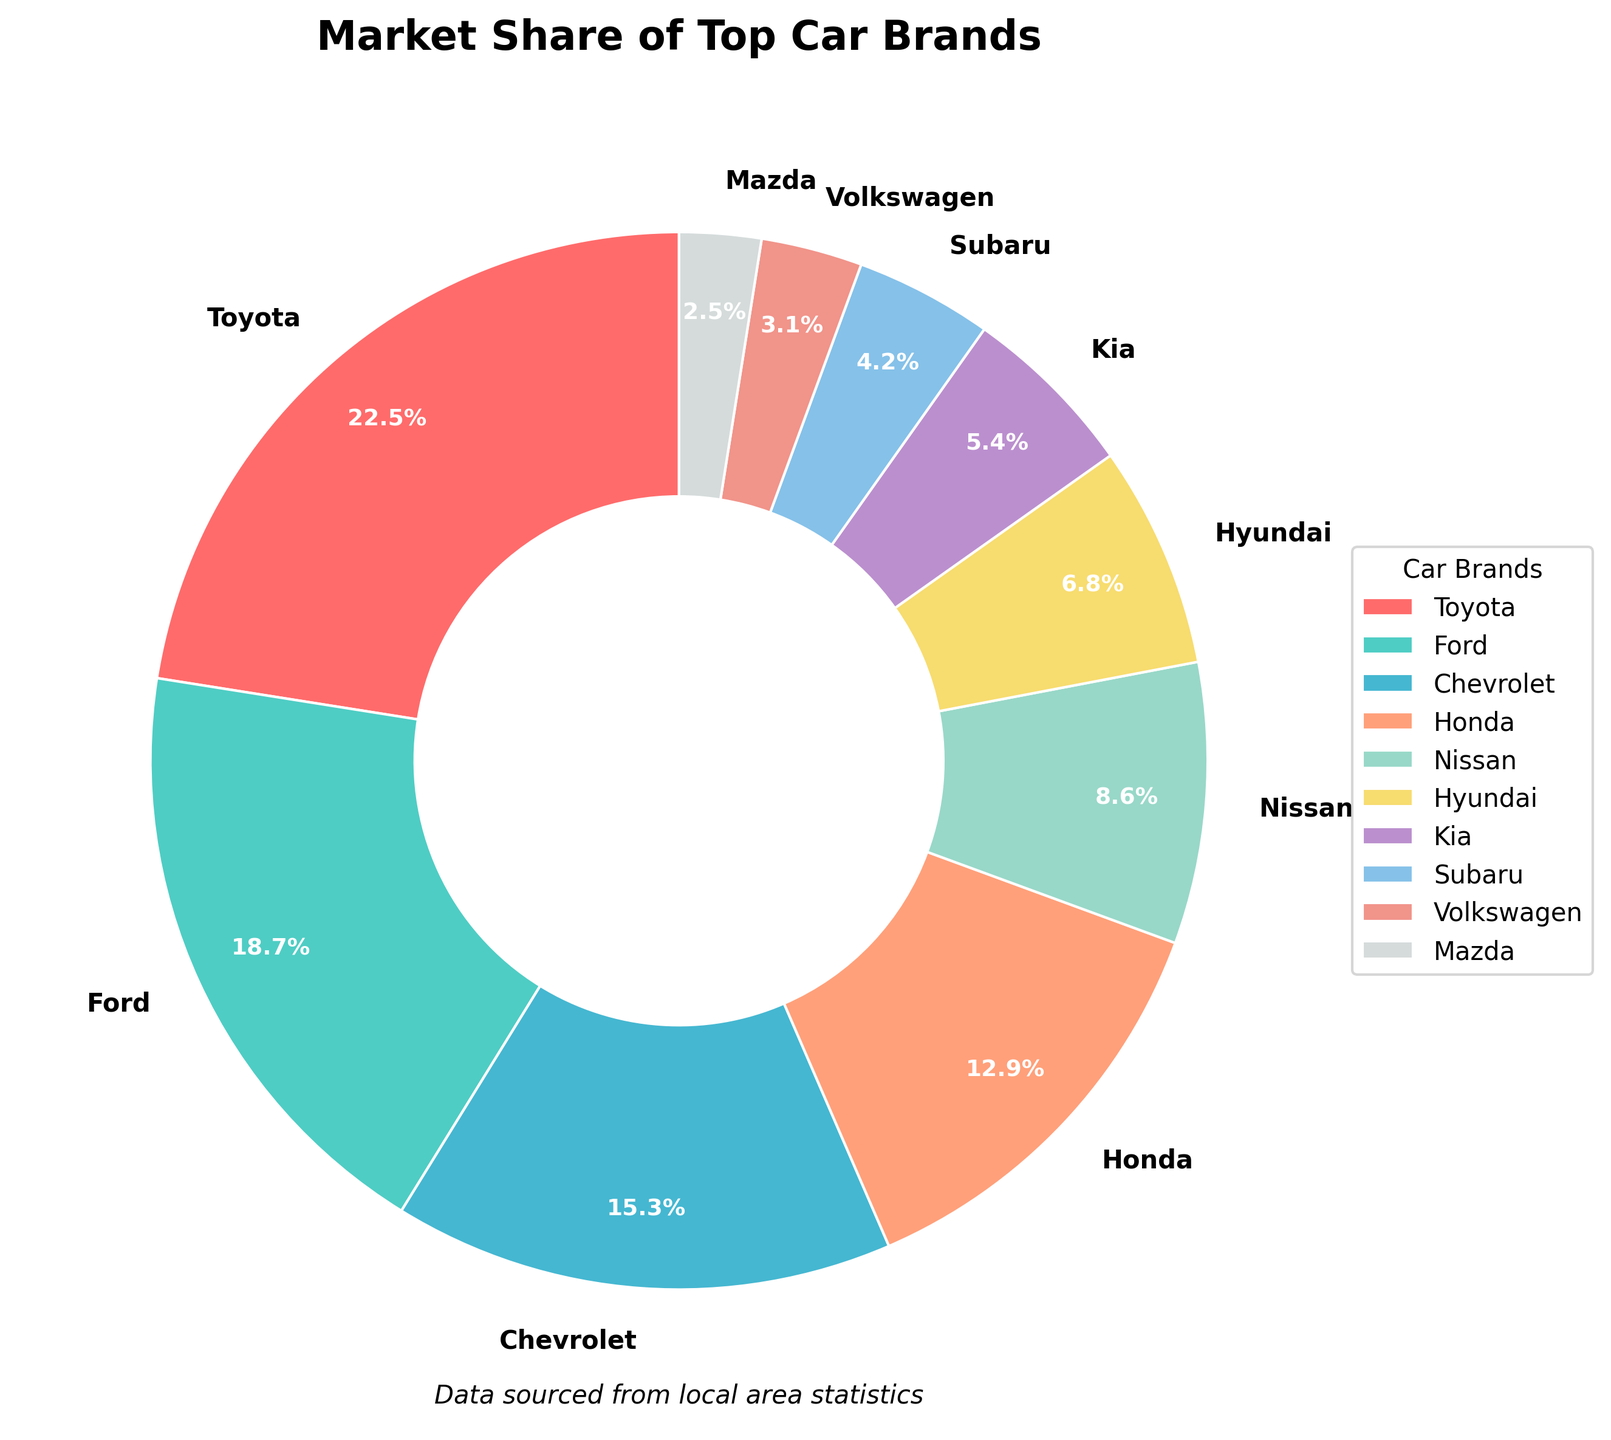What's the market share of the top three car brands combined? First, identify the market shares of the top three brands: Toyota (22.5%), Ford (18.7%), and Chevrolet (15.3%). Sum them up: 22.5% + 18.7% + 15.3% = 56.5%.
Answer: 56.5% Which brand has the smallest market share? Identify the brand with the smallest percentage in the Market Share section of the pie chart: Mazda (2.5%).
Answer: Mazda How much greater is Toyota's market share compared to Nissan's? Identify the market shares: Toyota (22.5%) and Nissan (8.6%). Subtract Nissan's share from Toyota's share: 22.5% - 8.6% = 13.9%.
Answer: 13.9% Which color represents Ford, and what is its market share? Locate Ford's segment in the pie chart (turquoise). Ford's market share is listed at 18.7%.
Answer: Turquoise, 18.7% List the brands that have a market share of at least 10%. Identify the brands with shares equal to or above 10%: Toyota (22.5%), Ford (18.7%), Chevrolet (15.3%), and Honda (12.9%).
Answer: Toyota, Ford, Chevrolet, Honda In terms of market share, which is larger: Hyundai and Kia combined or Nissan? Identify the market shares: Hyundai (6.8%) + Kia (5.4%) = 12.2%. Compare with Nissan's share (8.6%). Since 12.2% > 8.6%, Hyundai and Kia combined have a larger share.
Answer: Hyundai and Kia combined What's the average market share of the bottom five brands? Identify the bottom five brands' market shares: Subaru (4.2%), Volkswagen (3.1%), Mazda (2.5%), Kia (5.4%), and Hyundai (6.8%). Sum them up: 4.2% + 3.1% + 2.5% + 5.4% + 6.8% = 22.0%. Then calculate the average: 22.0% / 5 = 4.4%.
Answer: 4.4% Which two brands have market shares that, when combined, are closest to Honda's market share? Identify Honda's market share: 12.9%. Now, examine combinations: Nissan (8.6%) + Subaru (4.2%) = 12.8%, which is closest to 12.9%.
Answer: Nissan and Subaru Is Volkswagen's market share more than Mazda's and Subaru's combined? Identify the shares: Volkswagen (3.1%), Mazda (2.5%), Subaru (4.2%). Mazda and Subaru combined is 2.5% + 4.2% = 6.7%. Since 3.1% < 6.7%, Volkswagen's share is not more.
Answer: No 